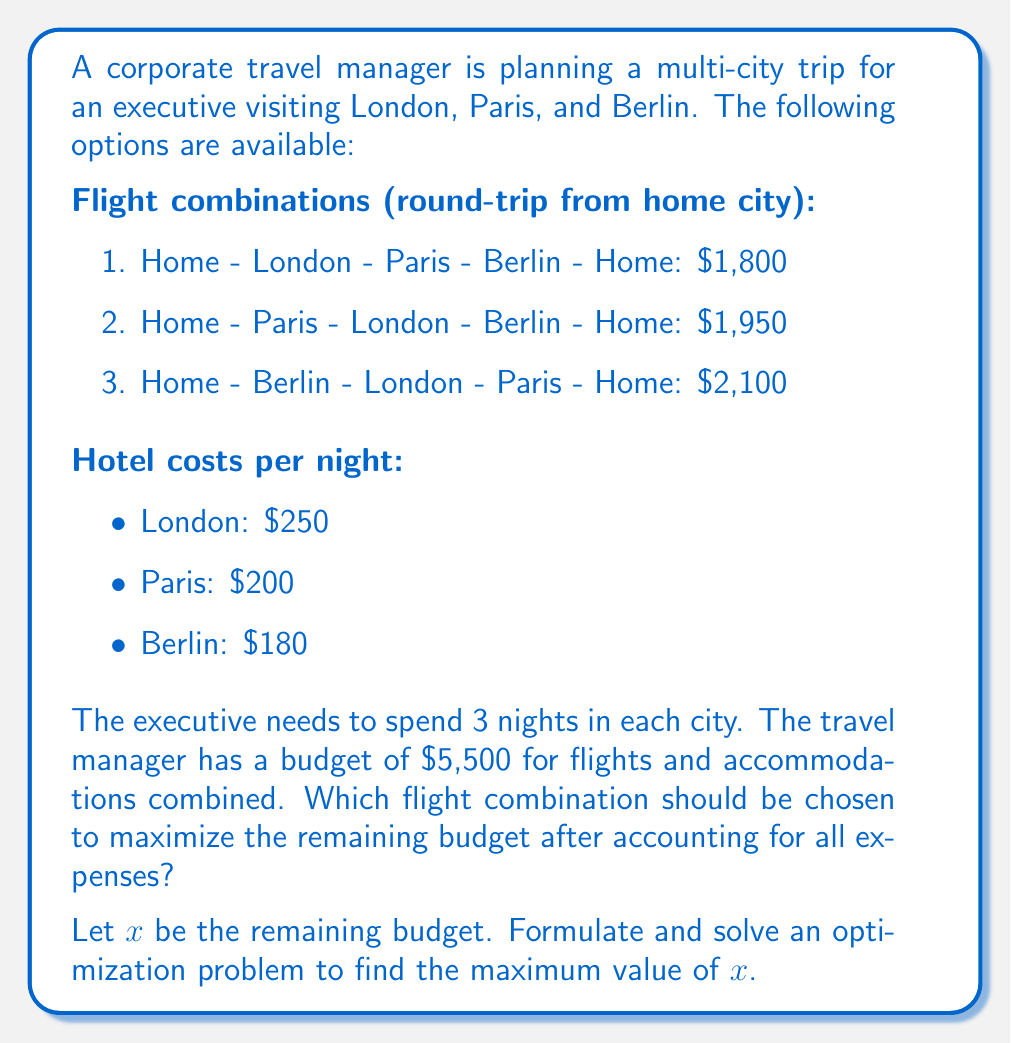Teach me how to tackle this problem. To solve this problem, we need to:
1. Calculate the total cost for each flight combination including hotel stays
2. Determine which combination is within budget and maximizes the remaining funds

Let's start by calculating the total cost for each option:

1. For each option, hotel costs remain the same:
   $$(3 \times $250) + (3 \times $200) + (3 \times $180) = $1,890$$

2. Total costs for each flight combination:
   Option 1: $1,800 + $1,890 = $3,690
   Option 2: $1,950 + $1,890 = $3,840
   Option 3: $2,100 + $1,890 = $3,990

3. Formulate the optimization problem:
   Maximize $x$ subject to:
   $$x = 5500 - \text{total cost}$$
   $$x \geq 0$$

4. Solve for each option:
   Option 1: $x = 5500 - 3690 = 1810$
   Option 2: $x = 5500 - 3840 = 1660$
   Option 3: $x = 5500 - 3990 = 1510$

5. Compare the results:
   Option 1 yields the highest remaining budget of $1,810, which is within the given budget constraint.

Therefore, the travel manager should choose flight combination 1 (Home - London - Paris - Berlin - Home) to maximize the remaining budget after accounting for all expenses.
Answer: The optimal solution is to choose flight combination 1 (Home - London - Paris - Berlin - Home), which results in a maximum remaining budget of $x = $1,810$. 